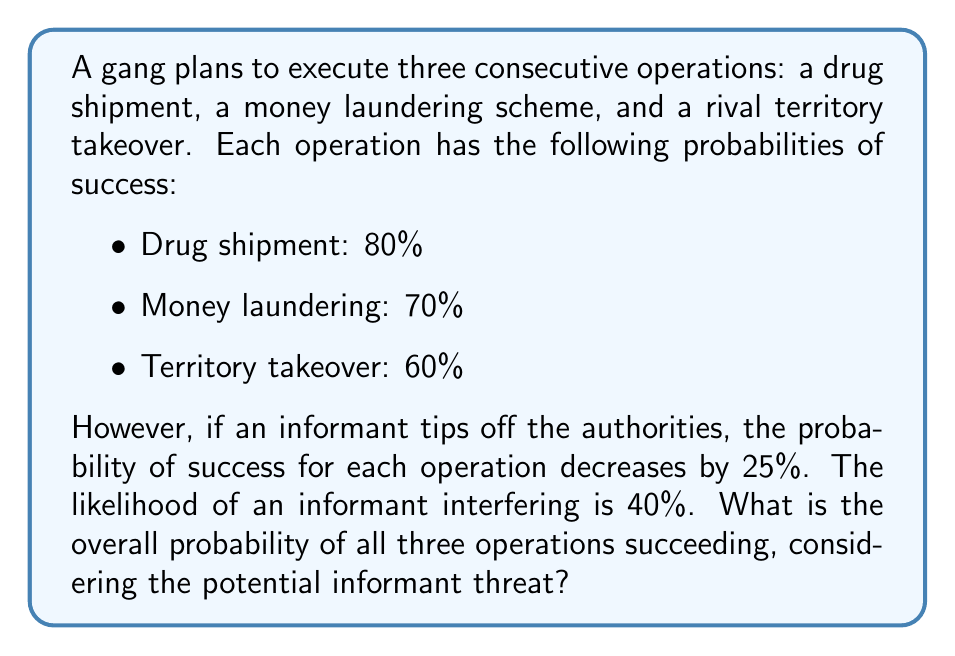Can you answer this question? Let's approach this step-by-step:

1) First, let's calculate the probability of success without an informant:
   $$P(\text{success without informant}) = 0.8 \times 0.7 \times 0.6 = 0.336 = 33.6\%$$

2) Now, if there's an informant, each probability decreases by 25%:
   - Drug shipment: $0.8 \times (1 - 0.25) = 0.6$
   - Money laundering: $0.7 \times (1 - 0.25) = 0.525$
   - Territory takeover: $0.6 \times (1 - 0.25) = 0.45$

3) The probability of success with an informant:
   $$P(\text{success with informant}) = 0.6 \times 0.525 \times 0.45 = 0.14175 = 14.175\%$$

4) Now, we can use the law of total probability:
   $$P(\text{total success}) = P(\text{no informant}) \times P(\text{success without informant}) + P(\text{informant}) \times P(\text{success with informant})$$

5) We know:
   $P(\text{no informant}) = 1 - 0.4 = 0.6$
   $P(\text{informant}) = 0.4$

6) Plugging in the values:
   $$P(\text{total success}) = 0.6 \times 0.336 + 0.4 \times 0.14175$$
   $$= 0.2016 + 0.0567 = 0.2583$$

7) Converting to a percentage:
   $$0.2583 \times 100\% = 25.83\%$$
Answer: 25.83% 